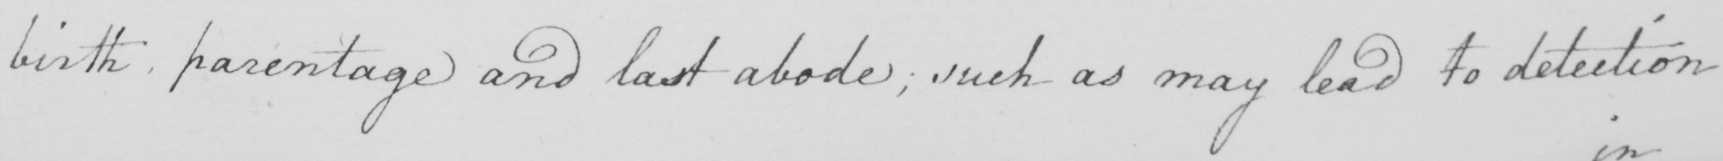Can you tell me what this handwritten text says? birth, parentage and last abode; such as may lead to detection 